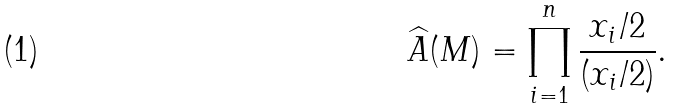Convert formula to latex. <formula><loc_0><loc_0><loc_500><loc_500>\widehat { A } ( M ) = \prod _ { i = 1 } ^ { n } \frac { x _ { i } / 2 } { ( x _ { i } / 2 ) } .</formula> 